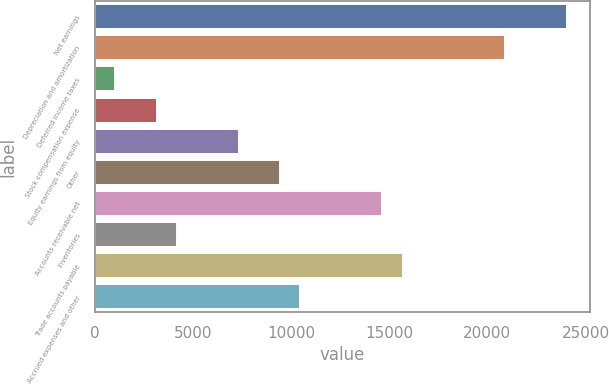<chart> <loc_0><loc_0><loc_500><loc_500><bar_chart><fcel>Net earnings<fcel>Depreciation and amortization<fcel>Deferred income taxes<fcel>Stock compensation expense<fcel>Equity earnings from equity<fcel>Other<fcel>Accounts receivable net<fcel>Inventories<fcel>Trade accounts payable<fcel>Accrued expenses and other<nl><fcel>24048.6<fcel>20913<fcel>1054.2<fcel>3144.6<fcel>7325.4<fcel>9415.8<fcel>14641.8<fcel>4189.8<fcel>15687<fcel>10461<nl></chart> 